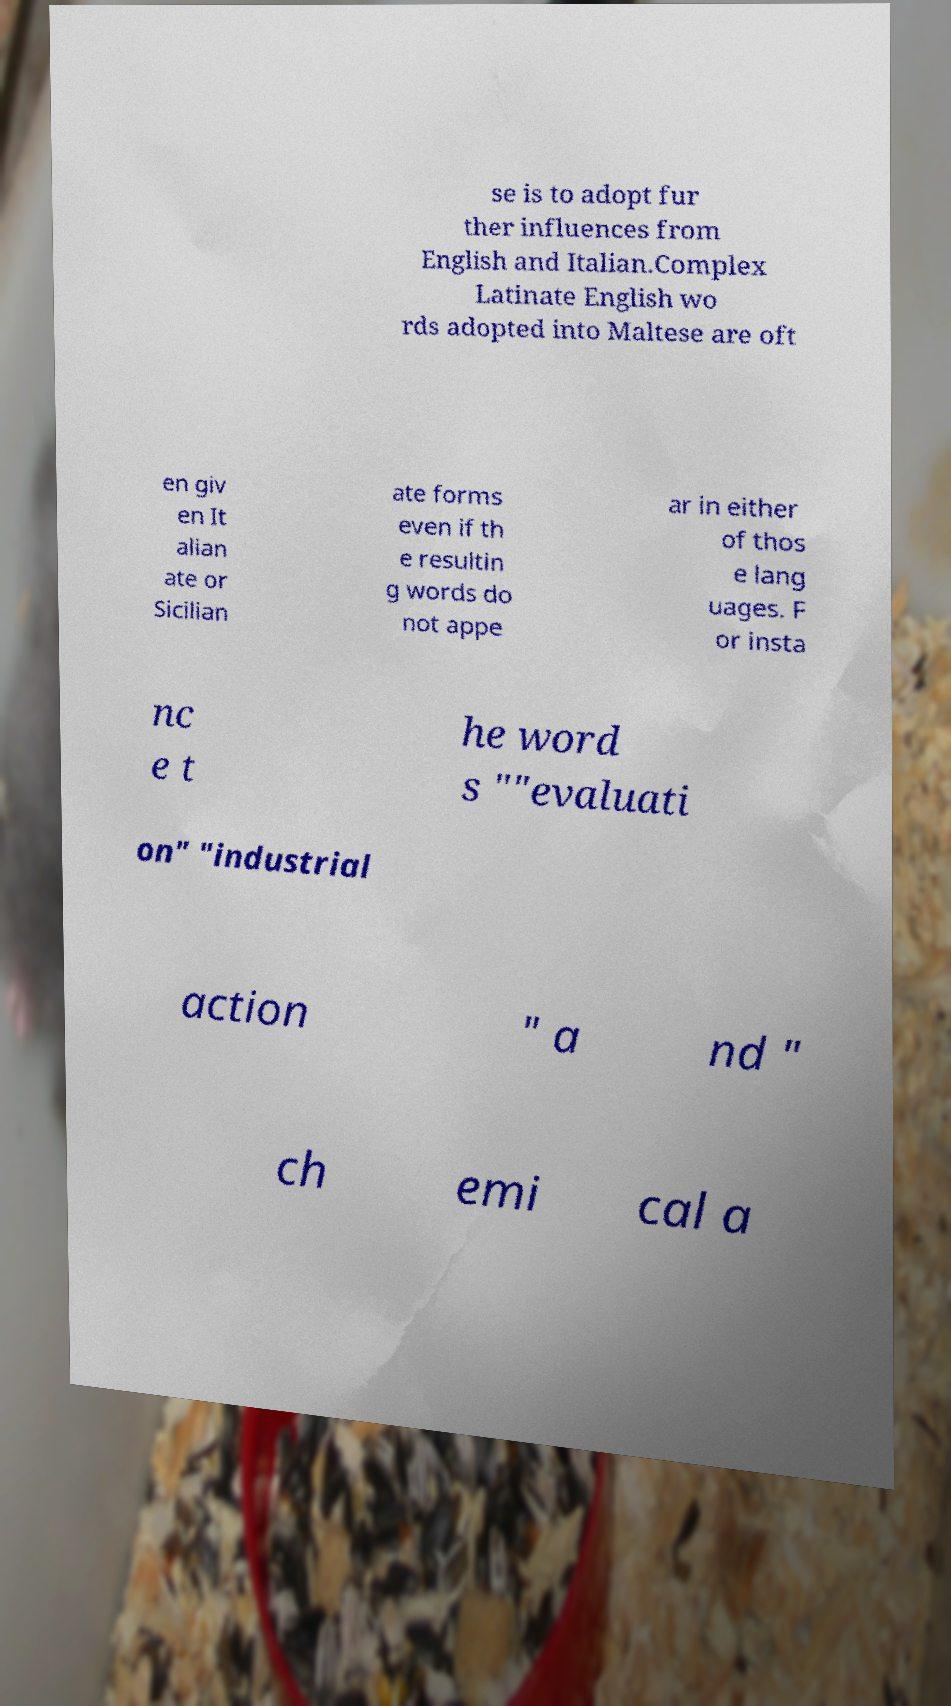Could you extract and type out the text from this image? se is to adopt fur ther influences from English and Italian.Complex Latinate English wo rds adopted into Maltese are oft en giv en It alian ate or Sicilian ate forms even if th e resultin g words do not appe ar in either of thos e lang uages. F or insta nc e t he word s ""evaluati on" "industrial action " a nd " ch emi cal a 